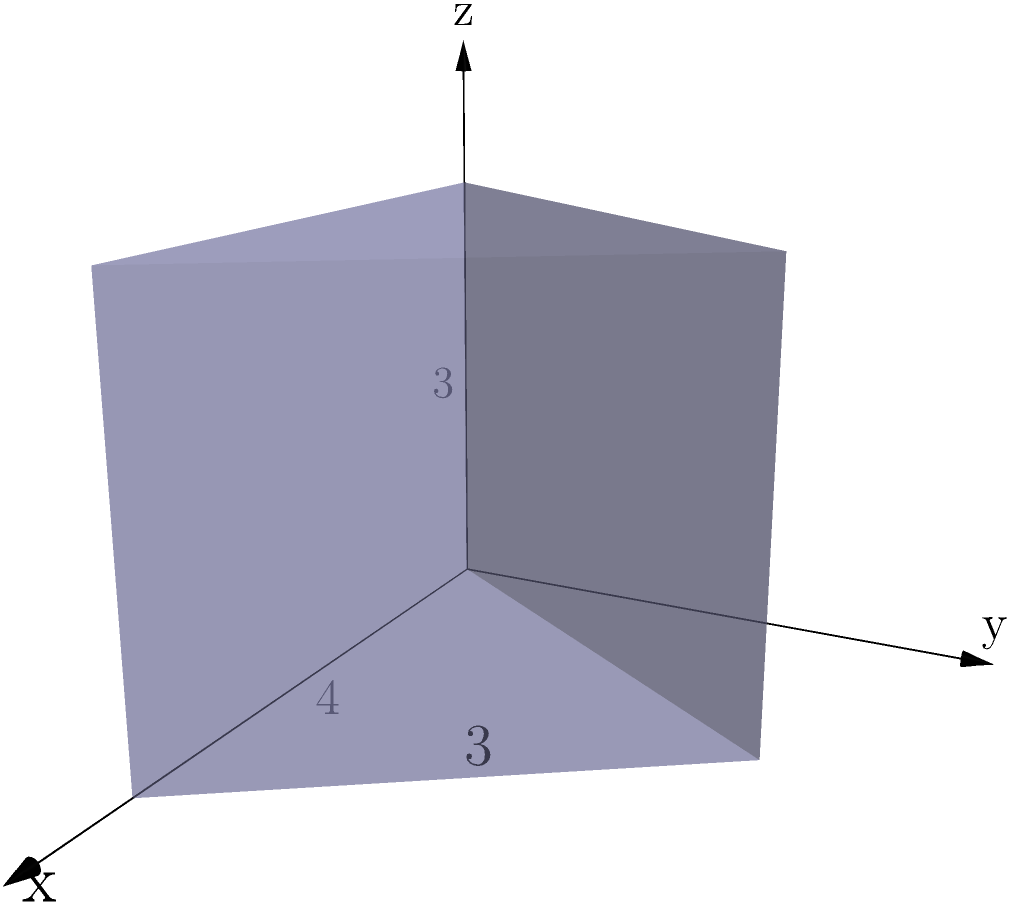A triangular prism represents the space created for personal growth through letting go of past grievances. The base of the prism is a right triangle with a base of 4 units and a height of 3 units, while the prism's height is 3 units. Calculate the volume of this prism, symbolizing the potential for emotional healing through forgiveness. To calculate the volume of a triangular prism, we need to follow these steps:

1. Calculate the area of the triangular base:
   The base is a right triangle with base $b = 4$ units and height $h = 3$ units.
   Area of the base = $\frac{1}{2} \times base \times height$
   $A_{base} = \frac{1}{2} \times 4 \times 3 = 6$ square units

2. Identify the height of the prism:
   The height of the prism is given as 3 units.

3. Apply the volume formula for a prism:
   Volume = Area of base $\times$ Height of prism
   $V = A_{base} \times H_{prism}$
   $V = 6 \times 3 = 18$ cubic units

The volume of the triangular prism is 18 cubic units, representing the space for personal growth achieved through forgiveness and letting go of emotional burdens.
Answer: 18 cubic units 